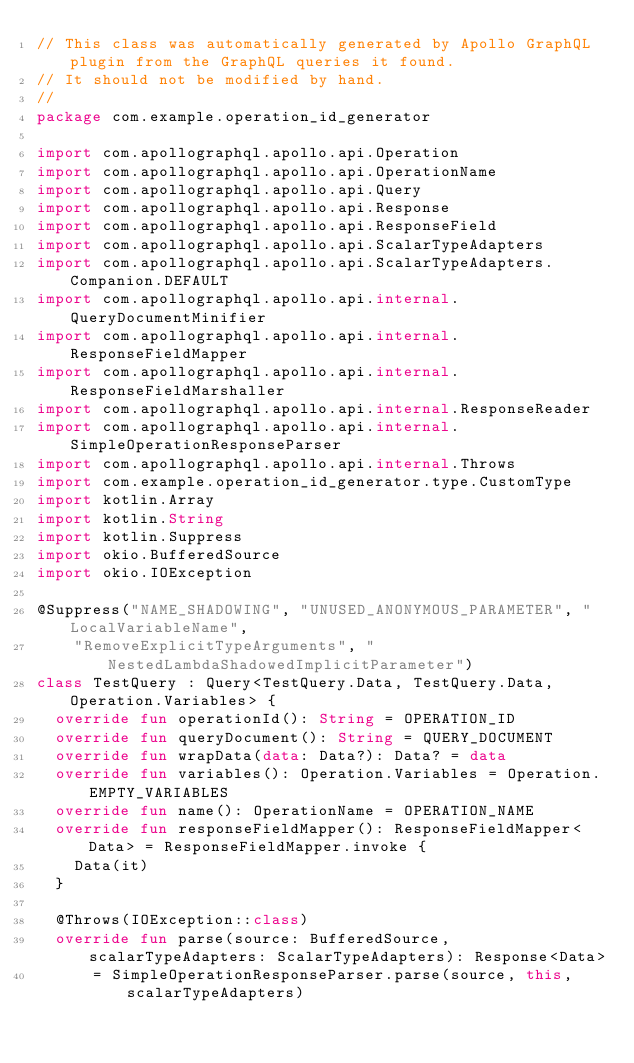Convert code to text. <code><loc_0><loc_0><loc_500><loc_500><_Kotlin_>// This class was automatically generated by Apollo GraphQL plugin from the GraphQL queries it found.
// It should not be modified by hand.
//
package com.example.operation_id_generator

import com.apollographql.apollo.api.Operation
import com.apollographql.apollo.api.OperationName
import com.apollographql.apollo.api.Query
import com.apollographql.apollo.api.Response
import com.apollographql.apollo.api.ResponseField
import com.apollographql.apollo.api.ScalarTypeAdapters
import com.apollographql.apollo.api.ScalarTypeAdapters.Companion.DEFAULT
import com.apollographql.apollo.api.internal.QueryDocumentMinifier
import com.apollographql.apollo.api.internal.ResponseFieldMapper
import com.apollographql.apollo.api.internal.ResponseFieldMarshaller
import com.apollographql.apollo.api.internal.ResponseReader
import com.apollographql.apollo.api.internal.SimpleOperationResponseParser
import com.apollographql.apollo.api.internal.Throws
import com.example.operation_id_generator.type.CustomType
import kotlin.Array
import kotlin.String
import kotlin.Suppress
import okio.BufferedSource
import okio.IOException

@Suppress("NAME_SHADOWING", "UNUSED_ANONYMOUS_PARAMETER", "LocalVariableName",
    "RemoveExplicitTypeArguments", "NestedLambdaShadowedImplicitParameter")
class TestQuery : Query<TestQuery.Data, TestQuery.Data, Operation.Variables> {
  override fun operationId(): String = OPERATION_ID
  override fun queryDocument(): String = QUERY_DOCUMENT
  override fun wrapData(data: Data?): Data? = data
  override fun variables(): Operation.Variables = Operation.EMPTY_VARIABLES
  override fun name(): OperationName = OPERATION_NAME
  override fun responseFieldMapper(): ResponseFieldMapper<Data> = ResponseFieldMapper.invoke {
    Data(it)
  }

  @Throws(IOException::class)
  override fun parse(source: BufferedSource, scalarTypeAdapters: ScalarTypeAdapters): Response<Data>
      = SimpleOperationResponseParser.parse(source, this, scalarTypeAdapters)
</code> 